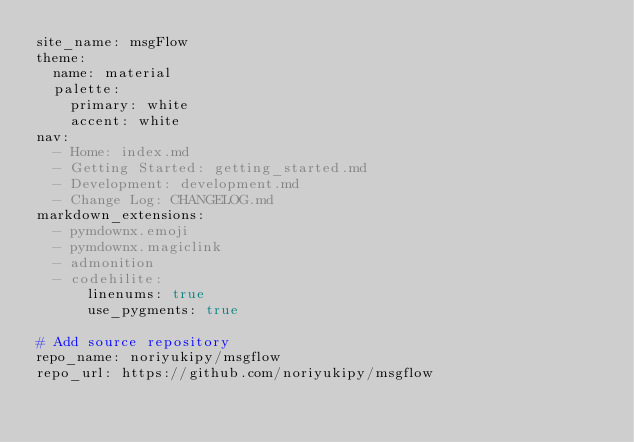<code> <loc_0><loc_0><loc_500><loc_500><_YAML_>site_name: msgFlow
theme:
  name: material
  palette:
    primary: white
    accent: white
nav:
  - Home: index.md
  - Getting Started: getting_started.md
  - Development: development.md
  - Change Log: CHANGELOG.md
markdown_extensions:
  - pymdownx.emoji
  - pymdownx.magiclink
  - admonition
  - codehilite:
      linenums: true
      use_pygments: true

# Add source repository
repo_name: noriyukipy/msgflow
repo_url: https://github.com/noriyukipy/msgflow</code> 